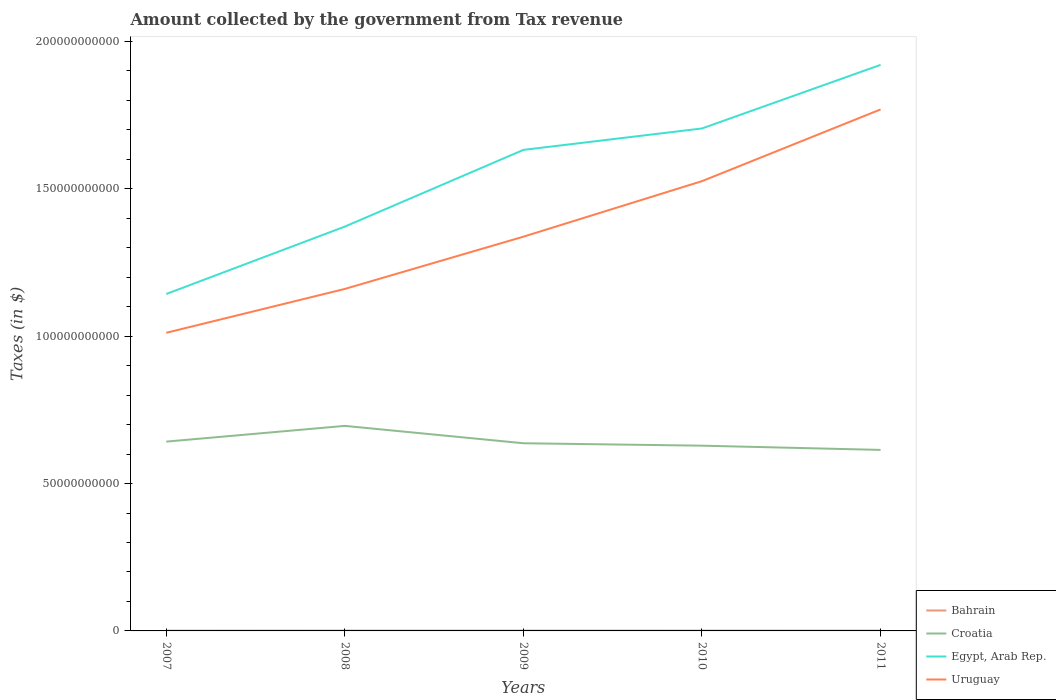Does the line corresponding to Bahrain intersect with the line corresponding to Croatia?
Ensure brevity in your answer.  No. Across all years, what is the maximum amount collected by the government from tax revenue in Bahrain?
Your response must be concise. 9.36e+07. What is the total amount collected by the government from tax revenue in Bahrain in the graph?
Give a very brief answer. -1.08e+06. What is the difference between the highest and the second highest amount collected by the government from tax revenue in Croatia?
Ensure brevity in your answer.  8.15e+09. How many lines are there?
Provide a short and direct response. 4. Does the graph contain any zero values?
Your answer should be very brief. No. Does the graph contain grids?
Give a very brief answer. No. Where does the legend appear in the graph?
Offer a terse response. Bottom right. How many legend labels are there?
Your answer should be compact. 4. What is the title of the graph?
Ensure brevity in your answer.  Amount collected by the government from Tax revenue. Does "Georgia" appear as one of the legend labels in the graph?
Keep it short and to the point. No. What is the label or title of the X-axis?
Offer a terse response. Years. What is the label or title of the Y-axis?
Your answer should be very brief. Taxes (in $). What is the Taxes (in $) of Bahrain in 2007?
Keep it short and to the point. 9.36e+07. What is the Taxes (in $) in Croatia in 2007?
Make the answer very short. 6.42e+1. What is the Taxes (in $) of Egypt, Arab Rep. in 2007?
Ensure brevity in your answer.  1.14e+11. What is the Taxes (in $) in Uruguay in 2007?
Your answer should be very brief. 1.01e+11. What is the Taxes (in $) of Bahrain in 2008?
Offer a very short reply. 1.19e+08. What is the Taxes (in $) of Croatia in 2008?
Make the answer very short. 6.96e+1. What is the Taxes (in $) in Egypt, Arab Rep. in 2008?
Offer a terse response. 1.37e+11. What is the Taxes (in $) in Uruguay in 2008?
Your answer should be compact. 1.16e+11. What is the Taxes (in $) of Bahrain in 2009?
Your answer should be very brief. 1.18e+08. What is the Taxes (in $) in Croatia in 2009?
Provide a short and direct response. 6.37e+1. What is the Taxes (in $) of Egypt, Arab Rep. in 2009?
Your answer should be compact. 1.63e+11. What is the Taxes (in $) in Uruguay in 2009?
Keep it short and to the point. 1.34e+11. What is the Taxes (in $) in Bahrain in 2010?
Make the answer very short. 1.14e+08. What is the Taxes (in $) in Croatia in 2010?
Provide a short and direct response. 6.29e+1. What is the Taxes (in $) in Egypt, Arab Rep. in 2010?
Provide a succinct answer. 1.70e+11. What is the Taxes (in $) in Uruguay in 2010?
Provide a short and direct response. 1.53e+11. What is the Taxes (in $) of Bahrain in 2011?
Your response must be concise. 1.21e+08. What is the Taxes (in $) in Croatia in 2011?
Offer a terse response. 6.14e+1. What is the Taxes (in $) of Egypt, Arab Rep. in 2011?
Make the answer very short. 1.92e+11. What is the Taxes (in $) in Uruguay in 2011?
Make the answer very short. 1.77e+11. Across all years, what is the maximum Taxes (in $) in Bahrain?
Provide a succinct answer. 1.21e+08. Across all years, what is the maximum Taxes (in $) in Croatia?
Give a very brief answer. 6.96e+1. Across all years, what is the maximum Taxes (in $) of Egypt, Arab Rep.?
Provide a short and direct response. 1.92e+11. Across all years, what is the maximum Taxes (in $) of Uruguay?
Provide a short and direct response. 1.77e+11. Across all years, what is the minimum Taxes (in $) in Bahrain?
Your answer should be compact. 9.36e+07. Across all years, what is the minimum Taxes (in $) of Croatia?
Provide a short and direct response. 6.14e+1. Across all years, what is the minimum Taxes (in $) of Egypt, Arab Rep.?
Ensure brevity in your answer.  1.14e+11. Across all years, what is the minimum Taxes (in $) of Uruguay?
Your answer should be very brief. 1.01e+11. What is the total Taxes (in $) in Bahrain in the graph?
Give a very brief answer. 5.65e+08. What is the total Taxes (in $) in Croatia in the graph?
Provide a short and direct response. 3.22e+11. What is the total Taxes (in $) in Egypt, Arab Rep. in the graph?
Provide a short and direct response. 7.77e+11. What is the total Taxes (in $) of Uruguay in the graph?
Your answer should be very brief. 6.81e+11. What is the difference between the Taxes (in $) in Bahrain in 2007 and that in 2008?
Your answer should be very brief. -2.59e+07. What is the difference between the Taxes (in $) in Croatia in 2007 and that in 2008?
Keep it short and to the point. -5.34e+09. What is the difference between the Taxes (in $) in Egypt, Arab Rep. in 2007 and that in 2008?
Your answer should be very brief. -2.29e+1. What is the difference between the Taxes (in $) in Uruguay in 2007 and that in 2008?
Your answer should be very brief. -1.49e+1. What is the difference between the Taxes (in $) of Bahrain in 2007 and that in 2009?
Keep it short and to the point. -2.40e+07. What is the difference between the Taxes (in $) in Croatia in 2007 and that in 2009?
Offer a terse response. 5.56e+08. What is the difference between the Taxes (in $) in Egypt, Arab Rep. in 2007 and that in 2009?
Ensure brevity in your answer.  -4.89e+1. What is the difference between the Taxes (in $) of Uruguay in 2007 and that in 2009?
Your answer should be compact. -3.26e+1. What is the difference between the Taxes (in $) of Bahrain in 2007 and that in 2010?
Make the answer very short. -2.02e+07. What is the difference between the Taxes (in $) in Croatia in 2007 and that in 2010?
Your answer should be very brief. 1.38e+09. What is the difference between the Taxes (in $) in Egypt, Arab Rep. in 2007 and that in 2010?
Your response must be concise. -5.62e+1. What is the difference between the Taxes (in $) of Uruguay in 2007 and that in 2010?
Your answer should be very brief. -5.15e+1. What is the difference between the Taxes (in $) of Bahrain in 2007 and that in 2011?
Provide a short and direct response. -2.70e+07. What is the difference between the Taxes (in $) in Croatia in 2007 and that in 2011?
Make the answer very short. 2.81e+09. What is the difference between the Taxes (in $) in Egypt, Arab Rep. in 2007 and that in 2011?
Offer a very short reply. -7.77e+1. What is the difference between the Taxes (in $) in Uruguay in 2007 and that in 2011?
Provide a short and direct response. -7.58e+1. What is the difference between the Taxes (in $) of Bahrain in 2008 and that in 2009?
Your response must be concise. 1.90e+06. What is the difference between the Taxes (in $) of Croatia in 2008 and that in 2009?
Ensure brevity in your answer.  5.89e+09. What is the difference between the Taxes (in $) in Egypt, Arab Rep. in 2008 and that in 2009?
Your answer should be compact. -2.60e+1. What is the difference between the Taxes (in $) of Uruguay in 2008 and that in 2009?
Your answer should be very brief. -1.77e+1. What is the difference between the Taxes (in $) of Bahrain in 2008 and that in 2010?
Your answer should be compact. 5.75e+06. What is the difference between the Taxes (in $) of Croatia in 2008 and that in 2010?
Provide a short and direct response. 6.72e+09. What is the difference between the Taxes (in $) in Egypt, Arab Rep. in 2008 and that in 2010?
Offer a terse response. -3.33e+1. What is the difference between the Taxes (in $) of Uruguay in 2008 and that in 2010?
Offer a terse response. -3.66e+1. What is the difference between the Taxes (in $) in Bahrain in 2008 and that in 2011?
Provide a short and direct response. -1.08e+06. What is the difference between the Taxes (in $) of Croatia in 2008 and that in 2011?
Keep it short and to the point. 8.15e+09. What is the difference between the Taxes (in $) of Egypt, Arab Rep. in 2008 and that in 2011?
Provide a short and direct response. -5.49e+1. What is the difference between the Taxes (in $) in Uruguay in 2008 and that in 2011?
Provide a short and direct response. -6.09e+1. What is the difference between the Taxes (in $) of Bahrain in 2009 and that in 2010?
Make the answer very short. 3.85e+06. What is the difference between the Taxes (in $) of Croatia in 2009 and that in 2010?
Give a very brief answer. 8.22e+08. What is the difference between the Taxes (in $) of Egypt, Arab Rep. in 2009 and that in 2010?
Ensure brevity in your answer.  -7.27e+09. What is the difference between the Taxes (in $) of Uruguay in 2009 and that in 2010?
Provide a succinct answer. -1.88e+1. What is the difference between the Taxes (in $) of Bahrain in 2009 and that in 2011?
Ensure brevity in your answer.  -2.98e+06. What is the difference between the Taxes (in $) of Croatia in 2009 and that in 2011?
Offer a terse response. 2.26e+09. What is the difference between the Taxes (in $) in Egypt, Arab Rep. in 2009 and that in 2011?
Ensure brevity in your answer.  -2.88e+1. What is the difference between the Taxes (in $) in Uruguay in 2009 and that in 2011?
Your answer should be compact. -4.32e+1. What is the difference between the Taxes (in $) of Bahrain in 2010 and that in 2011?
Provide a short and direct response. -6.83e+06. What is the difference between the Taxes (in $) of Croatia in 2010 and that in 2011?
Your answer should be very brief. 1.43e+09. What is the difference between the Taxes (in $) in Egypt, Arab Rep. in 2010 and that in 2011?
Your answer should be very brief. -2.16e+1. What is the difference between the Taxes (in $) in Uruguay in 2010 and that in 2011?
Give a very brief answer. -2.43e+1. What is the difference between the Taxes (in $) of Bahrain in 2007 and the Taxes (in $) of Croatia in 2008?
Give a very brief answer. -6.95e+1. What is the difference between the Taxes (in $) of Bahrain in 2007 and the Taxes (in $) of Egypt, Arab Rep. in 2008?
Your response must be concise. -1.37e+11. What is the difference between the Taxes (in $) of Bahrain in 2007 and the Taxes (in $) of Uruguay in 2008?
Your answer should be compact. -1.16e+11. What is the difference between the Taxes (in $) in Croatia in 2007 and the Taxes (in $) in Egypt, Arab Rep. in 2008?
Make the answer very short. -7.30e+1. What is the difference between the Taxes (in $) of Croatia in 2007 and the Taxes (in $) of Uruguay in 2008?
Your answer should be compact. -5.18e+1. What is the difference between the Taxes (in $) in Egypt, Arab Rep. in 2007 and the Taxes (in $) in Uruguay in 2008?
Ensure brevity in your answer.  -1.72e+09. What is the difference between the Taxes (in $) of Bahrain in 2007 and the Taxes (in $) of Croatia in 2009?
Offer a very short reply. -6.36e+1. What is the difference between the Taxes (in $) in Bahrain in 2007 and the Taxes (in $) in Egypt, Arab Rep. in 2009?
Ensure brevity in your answer.  -1.63e+11. What is the difference between the Taxes (in $) in Bahrain in 2007 and the Taxes (in $) in Uruguay in 2009?
Keep it short and to the point. -1.34e+11. What is the difference between the Taxes (in $) in Croatia in 2007 and the Taxes (in $) in Egypt, Arab Rep. in 2009?
Ensure brevity in your answer.  -9.90e+1. What is the difference between the Taxes (in $) in Croatia in 2007 and the Taxes (in $) in Uruguay in 2009?
Keep it short and to the point. -6.95e+1. What is the difference between the Taxes (in $) of Egypt, Arab Rep. in 2007 and the Taxes (in $) of Uruguay in 2009?
Your answer should be compact. -1.94e+1. What is the difference between the Taxes (in $) in Bahrain in 2007 and the Taxes (in $) in Croatia in 2010?
Offer a terse response. -6.28e+1. What is the difference between the Taxes (in $) of Bahrain in 2007 and the Taxes (in $) of Egypt, Arab Rep. in 2010?
Ensure brevity in your answer.  -1.70e+11. What is the difference between the Taxes (in $) in Bahrain in 2007 and the Taxes (in $) in Uruguay in 2010?
Your response must be concise. -1.53e+11. What is the difference between the Taxes (in $) in Croatia in 2007 and the Taxes (in $) in Egypt, Arab Rep. in 2010?
Make the answer very short. -1.06e+11. What is the difference between the Taxes (in $) of Croatia in 2007 and the Taxes (in $) of Uruguay in 2010?
Your answer should be very brief. -8.84e+1. What is the difference between the Taxes (in $) of Egypt, Arab Rep. in 2007 and the Taxes (in $) of Uruguay in 2010?
Give a very brief answer. -3.83e+1. What is the difference between the Taxes (in $) in Bahrain in 2007 and the Taxes (in $) in Croatia in 2011?
Your answer should be very brief. -6.13e+1. What is the difference between the Taxes (in $) in Bahrain in 2007 and the Taxes (in $) in Egypt, Arab Rep. in 2011?
Provide a short and direct response. -1.92e+11. What is the difference between the Taxes (in $) in Bahrain in 2007 and the Taxes (in $) in Uruguay in 2011?
Provide a succinct answer. -1.77e+11. What is the difference between the Taxes (in $) in Croatia in 2007 and the Taxes (in $) in Egypt, Arab Rep. in 2011?
Keep it short and to the point. -1.28e+11. What is the difference between the Taxes (in $) in Croatia in 2007 and the Taxes (in $) in Uruguay in 2011?
Your response must be concise. -1.13e+11. What is the difference between the Taxes (in $) of Egypt, Arab Rep. in 2007 and the Taxes (in $) of Uruguay in 2011?
Your response must be concise. -6.26e+1. What is the difference between the Taxes (in $) in Bahrain in 2008 and the Taxes (in $) in Croatia in 2009?
Offer a very short reply. -6.36e+1. What is the difference between the Taxes (in $) in Bahrain in 2008 and the Taxes (in $) in Egypt, Arab Rep. in 2009?
Ensure brevity in your answer.  -1.63e+11. What is the difference between the Taxes (in $) of Bahrain in 2008 and the Taxes (in $) of Uruguay in 2009?
Your response must be concise. -1.34e+11. What is the difference between the Taxes (in $) of Croatia in 2008 and the Taxes (in $) of Egypt, Arab Rep. in 2009?
Your answer should be very brief. -9.36e+1. What is the difference between the Taxes (in $) in Croatia in 2008 and the Taxes (in $) in Uruguay in 2009?
Keep it short and to the point. -6.42e+1. What is the difference between the Taxes (in $) of Egypt, Arab Rep. in 2008 and the Taxes (in $) of Uruguay in 2009?
Provide a short and direct response. 3.42e+09. What is the difference between the Taxes (in $) in Bahrain in 2008 and the Taxes (in $) in Croatia in 2010?
Give a very brief answer. -6.27e+1. What is the difference between the Taxes (in $) of Bahrain in 2008 and the Taxes (in $) of Egypt, Arab Rep. in 2010?
Offer a very short reply. -1.70e+11. What is the difference between the Taxes (in $) in Bahrain in 2008 and the Taxes (in $) in Uruguay in 2010?
Offer a very short reply. -1.52e+11. What is the difference between the Taxes (in $) of Croatia in 2008 and the Taxes (in $) of Egypt, Arab Rep. in 2010?
Provide a short and direct response. -1.01e+11. What is the difference between the Taxes (in $) of Croatia in 2008 and the Taxes (in $) of Uruguay in 2010?
Keep it short and to the point. -8.30e+1. What is the difference between the Taxes (in $) of Egypt, Arab Rep. in 2008 and the Taxes (in $) of Uruguay in 2010?
Ensure brevity in your answer.  -1.54e+1. What is the difference between the Taxes (in $) in Bahrain in 2008 and the Taxes (in $) in Croatia in 2011?
Provide a succinct answer. -6.13e+1. What is the difference between the Taxes (in $) in Bahrain in 2008 and the Taxes (in $) in Egypt, Arab Rep. in 2011?
Provide a short and direct response. -1.92e+11. What is the difference between the Taxes (in $) of Bahrain in 2008 and the Taxes (in $) of Uruguay in 2011?
Offer a very short reply. -1.77e+11. What is the difference between the Taxes (in $) in Croatia in 2008 and the Taxes (in $) in Egypt, Arab Rep. in 2011?
Your answer should be very brief. -1.22e+11. What is the difference between the Taxes (in $) of Croatia in 2008 and the Taxes (in $) of Uruguay in 2011?
Your answer should be compact. -1.07e+11. What is the difference between the Taxes (in $) of Egypt, Arab Rep. in 2008 and the Taxes (in $) of Uruguay in 2011?
Ensure brevity in your answer.  -3.98e+1. What is the difference between the Taxes (in $) of Bahrain in 2009 and the Taxes (in $) of Croatia in 2010?
Ensure brevity in your answer.  -6.27e+1. What is the difference between the Taxes (in $) of Bahrain in 2009 and the Taxes (in $) of Egypt, Arab Rep. in 2010?
Offer a terse response. -1.70e+11. What is the difference between the Taxes (in $) of Bahrain in 2009 and the Taxes (in $) of Uruguay in 2010?
Offer a terse response. -1.52e+11. What is the difference between the Taxes (in $) in Croatia in 2009 and the Taxes (in $) in Egypt, Arab Rep. in 2010?
Provide a short and direct response. -1.07e+11. What is the difference between the Taxes (in $) of Croatia in 2009 and the Taxes (in $) of Uruguay in 2010?
Keep it short and to the point. -8.89e+1. What is the difference between the Taxes (in $) in Egypt, Arab Rep. in 2009 and the Taxes (in $) in Uruguay in 2010?
Make the answer very short. 1.06e+1. What is the difference between the Taxes (in $) of Bahrain in 2009 and the Taxes (in $) of Croatia in 2011?
Provide a succinct answer. -6.13e+1. What is the difference between the Taxes (in $) in Bahrain in 2009 and the Taxes (in $) in Egypt, Arab Rep. in 2011?
Give a very brief answer. -1.92e+11. What is the difference between the Taxes (in $) of Bahrain in 2009 and the Taxes (in $) of Uruguay in 2011?
Offer a very short reply. -1.77e+11. What is the difference between the Taxes (in $) in Croatia in 2009 and the Taxes (in $) in Egypt, Arab Rep. in 2011?
Ensure brevity in your answer.  -1.28e+11. What is the difference between the Taxes (in $) in Croatia in 2009 and the Taxes (in $) in Uruguay in 2011?
Offer a very short reply. -1.13e+11. What is the difference between the Taxes (in $) in Egypt, Arab Rep. in 2009 and the Taxes (in $) in Uruguay in 2011?
Offer a terse response. -1.37e+1. What is the difference between the Taxes (in $) in Bahrain in 2010 and the Taxes (in $) in Croatia in 2011?
Give a very brief answer. -6.13e+1. What is the difference between the Taxes (in $) in Bahrain in 2010 and the Taxes (in $) in Egypt, Arab Rep. in 2011?
Give a very brief answer. -1.92e+11. What is the difference between the Taxes (in $) in Bahrain in 2010 and the Taxes (in $) in Uruguay in 2011?
Provide a succinct answer. -1.77e+11. What is the difference between the Taxes (in $) in Croatia in 2010 and the Taxes (in $) in Egypt, Arab Rep. in 2011?
Keep it short and to the point. -1.29e+11. What is the difference between the Taxes (in $) of Croatia in 2010 and the Taxes (in $) of Uruguay in 2011?
Provide a succinct answer. -1.14e+11. What is the difference between the Taxes (in $) of Egypt, Arab Rep. in 2010 and the Taxes (in $) of Uruguay in 2011?
Keep it short and to the point. -6.46e+09. What is the average Taxes (in $) of Bahrain per year?
Ensure brevity in your answer.  1.13e+08. What is the average Taxes (in $) in Croatia per year?
Provide a short and direct response. 6.44e+1. What is the average Taxes (in $) in Egypt, Arab Rep. per year?
Provide a succinct answer. 1.55e+11. What is the average Taxes (in $) in Uruguay per year?
Provide a short and direct response. 1.36e+11. In the year 2007, what is the difference between the Taxes (in $) in Bahrain and Taxes (in $) in Croatia?
Make the answer very short. -6.41e+1. In the year 2007, what is the difference between the Taxes (in $) in Bahrain and Taxes (in $) in Egypt, Arab Rep.?
Keep it short and to the point. -1.14e+11. In the year 2007, what is the difference between the Taxes (in $) in Bahrain and Taxes (in $) in Uruguay?
Your answer should be compact. -1.01e+11. In the year 2007, what is the difference between the Taxes (in $) in Croatia and Taxes (in $) in Egypt, Arab Rep.?
Your answer should be compact. -5.01e+1. In the year 2007, what is the difference between the Taxes (in $) in Croatia and Taxes (in $) in Uruguay?
Offer a very short reply. -3.69e+1. In the year 2007, what is the difference between the Taxes (in $) of Egypt, Arab Rep. and Taxes (in $) of Uruguay?
Offer a very short reply. 1.32e+1. In the year 2008, what is the difference between the Taxes (in $) of Bahrain and Taxes (in $) of Croatia?
Keep it short and to the point. -6.95e+1. In the year 2008, what is the difference between the Taxes (in $) of Bahrain and Taxes (in $) of Egypt, Arab Rep.?
Provide a succinct answer. -1.37e+11. In the year 2008, what is the difference between the Taxes (in $) of Bahrain and Taxes (in $) of Uruguay?
Provide a succinct answer. -1.16e+11. In the year 2008, what is the difference between the Taxes (in $) in Croatia and Taxes (in $) in Egypt, Arab Rep.?
Offer a very short reply. -6.76e+1. In the year 2008, what is the difference between the Taxes (in $) of Croatia and Taxes (in $) of Uruguay?
Give a very brief answer. -4.65e+1. In the year 2008, what is the difference between the Taxes (in $) in Egypt, Arab Rep. and Taxes (in $) in Uruguay?
Make the answer very short. 2.11e+1. In the year 2009, what is the difference between the Taxes (in $) of Bahrain and Taxes (in $) of Croatia?
Make the answer very short. -6.36e+1. In the year 2009, what is the difference between the Taxes (in $) of Bahrain and Taxes (in $) of Egypt, Arab Rep.?
Ensure brevity in your answer.  -1.63e+11. In the year 2009, what is the difference between the Taxes (in $) of Bahrain and Taxes (in $) of Uruguay?
Make the answer very short. -1.34e+11. In the year 2009, what is the difference between the Taxes (in $) in Croatia and Taxes (in $) in Egypt, Arab Rep.?
Your response must be concise. -9.95e+1. In the year 2009, what is the difference between the Taxes (in $) in Croatia and Taxes (in $) in Uruguay?
Provide a short and direct response. -7.01e+1. In the year 2009, what is the difference between the Taxes (in $) in Egypt, Arab Rep. and Taxes (in $) in Uruguay?
Ensure brevity in your answer.  2.94e+1. In the year 2010, what is the difference between the Taxes (in $) of Bahrain and Taxes (in $) of Croatia?
Your answer should be compact. -6.27e+1. In the year 2010, what is the difference between the Taxes (in $) in Bahrain and Taxes (in $) in Egypt, Arab Rep.?
Keep it short and to the point. -1.70e+11. In the year 2010, what is the difference between the Taxes (in $) of Bahrain and Taxes (in $) of Uruguay?
Provide a short and direct response. -1.53e+11. In the year 2010, what is the difference between the Taxes (in $) of Croatia and Taxes (in $) of Egypt, Arab Rep.?
Provide a succinct answer. -1.08e+11. In the year 2010, what is the difference between the Taxes (in $) of Croatia and Taxes (in $) of Uruguay?
Offer a terse response. -8.98e+1. In the year 2010, what is the difference between the Taxes (in $) in Egypt, Arab Rep. and Taxes (in $) in Uruguay?
Your response must be concise. 1.79e+1. In the year 2011, what is the difference between the Taxes (in $) in Bahrain and Taxes (in $) in Croatia?
Offer a terse response. -6.13e+1. In the year 2011, what is the difference between the Taxes (in $) in Bahrain and Taxes (in $) in Egypt, Arab Rep.?
Your answer should be compact. -1.92e+11. In the year 2011, what is the difference between the Taxes (in $) in Bahrain and Taxes (in $) in Uruguay?
Offer a very short reply. -1.77e+11. In the year 2011, what is the difference between the Taxes (in $) of Croatia and Taxes (in $) of Egypt, Arab Rep.?
Offer a very short reply. -1.31e+11. In the year 2011, what is the difference between the Taxes (in $) of Croatia and Taxes (in $) of Uruguay?
Offer a terse response. -1.16e+11. In the year 2011, what is the difference between the Taxes (in $) in Egypt, Arab Rep. and Taxes (in $) in Uruguay?
Your answer should be very brief. 1.51e+1. What is the ratio of the Taxes (in $) in Bahrain in 2007 to that in 2008?
Your answer should be compact. 0.78. What is the ratio of the Taxes (in $) in Croatia in 2007 to that in 2008?
Provide a short and direct response. 0.92. What is the ratio of the Taxes (in $) of Uruguay in 2007 to that in 2008?
Keep it short and to the point. 0.87. What is the ratio of the Taxes (in $) in Bahrain in 2007 to that in 2009?
Provide a short and direct response. 0.8. What is the ratio of the Taxes (in $) of Croatia in 2007 to that in 2009?
Make the answer very short. 1.01. What is the ratio of the Taxes (in $) in Egypt, Arab Rep. in 2007 to that in 2009?
Provide a short and direct response. 0.7. What is the ratio of the Taxes (in $) of Uruguay in 2007 to that in 2009?
Make the answer very short. 0.76. What is the ratio of the Taxes (in $) of Bahrain in 2007 to that in 2010?
Make the answer very short. 0.82. What is the ratio of the Taxes (in $) in Croatia in 2007 to that in 2010?
Your response must be concise. 1.02. What is the ratio of the Taxes (in $) in Egypt, Arab Rep. in 2007 to that in 2010?
Your answer should be very brief. 0.67. What is the ratio of the Taxes (in $) in Uruguay in 2007 to that in 2010?
Your response must be concise. 0.66. What is the ratio of the Taxes (in $) in Bahrain in 2007 to that in 2011?
Provide a succinct answer. 0.78. What is the ratio of the Taxes (in $) in Croatia in 2007 to that in 2011?
Provide a short and direct response. 1.05. What is the ratio of the Taxes (in $) in Egypt, Arab Rep. in 2007 to that in 2011?
Your response must be concise. 0.6. What is the ratio of the Taxes (in $) in Uruguay in 2007 to that in 2011?
Keep it short and to the point. 0.57. What is the ratio of the Taxes (in $) of Bahrain in 2008 to that in 2009?
Your response must be concise. 1.02. What is the ratio of the Taxes (in $) of Croatia in 2008 to that in 2009?
Offer a terse response. 1.09. What is the ratio of the Taxes (in $) of Egypt, Arab Rep. in 2008 to that in 2009?
Your answer should be compact. 0.84. What is the ratio of the Taxes (in $) of Uruguay in 2008 to that in 2009?
Keep it short and to the point. 0.87. What is the ratio of the Taxes (in $) of Bahrain in 2008 to that in 2010?
Provide a succinct answer. 1.05. What is the ratio of the Taxes (in $) in Croatia in 2008 to that in 2010?
Provide a short and direct response. 1.11. What is the ratio of the Taxes (in $) of Egypt, Arab Rep. in 2008 to that in 2010?
Provide a short and direct response. 0.8. What is the ratio of the Taxes (in $) in Uruguay in 2008 to that in 2010?
Provide a succinct answer. 0.76. What is the ratio of the Taxes (in $) of Croatia in 2008 to that in 2011?
Make the answer very short. 1.13. What is the ratio of the Taxes (in $) in Egypt, Arab Rep. in 2008 to that in 2011?
Provide a short and direct response. 0.71. What is the ratio of the Taxes (in $) in Uruguay in 2008 to that in 2011?
Your answer should be compact. 0.66. What is the ratio of the Taxes (in $) of Bahrain in 2009 to that in 2010?
Ensure brevity in your answer.  1.03. What is the ratio of the Taxes (in $) in Croatia in 2009 to that in 2010?
Ensure brevity in your answer.  1.01. What is the ratio of the Taxes (in $) in Egypt, Arab Rep. in 2009 to that in 2010?
Ensure brevity in your answer.  0.96. What is the ratio of the Taxes (in $) in Uruguay in 2009 to that in 2010?
Give a very brief answer. 0.88. What is the ratio of the Taxes (in $) of Bahrain in 2009 to that in 2011?
Give a very brief answer. 0.98. What is the ratio of the Taxes (in $) of Croatia in 2009 to that in 2011?
Make the answer very short. 1.04. What is the ratio of the Taxes (in $) in Egypt, Arab Rep. in 2009 to that in 2011?
Your response must be concise. 0.85. What is the ratio of the Taxes (in $) in Uruguay in 2009 to that in 2011?
Provide a succinct answer. 0.76. What is the ratio of the Taxes (in $) of Bahrain in 2010 to that in 2011?
Provide a succinct answer. 0.94. What is the ratio of the Taxes (in $) of Croatia in 2010 to that in 2011?
Keep it short and to the point. 1.02. What is the ratio of the Taxes (in $) of Egypt, Arab Rep. in 2010 to that in 2011?
Give a very brief answer. 0.89. What is the ratio of the Taxes (in $) in Uruguay in 2010 to that in 2011?
Offer a very short reply. 0.86. What is the difference between the highest and the second highest Taxes (in $) of Bahrain?
Ensure brevity in your answer.  1.08e+06. What is the difference between the highest and the second highest Taxes (in $) of Croatia?
Offer a terse response. 5.34e+09. What is the difference between the highest and the second highest Taxes (in $) in Egypt, Arab Rep.?
Make the answer very short. 2.16e+1. What is the difference between the highest and the second highest Taxes (in $) in Uruguay?
Keep it short and to the point. 2.43e+1. What is the difference between the highest and the lowest Taxes (in $) of Bahrain?
Offer a very short reply. 2.70e+07. What is the difference between the highest and the lowest Taxes (in $) of Croatia?
Make the answer very short. 8.15e+09. What is the difference between the highest and the lowest Taxes (in $) of Egypt, Arab Rep.?
Ensure brevity in your answer.  7.77e+1. What is the difference between the highest and the lowest Taxes (in $) in Uruguay?
Offer a terse response. 7.58e+1. 